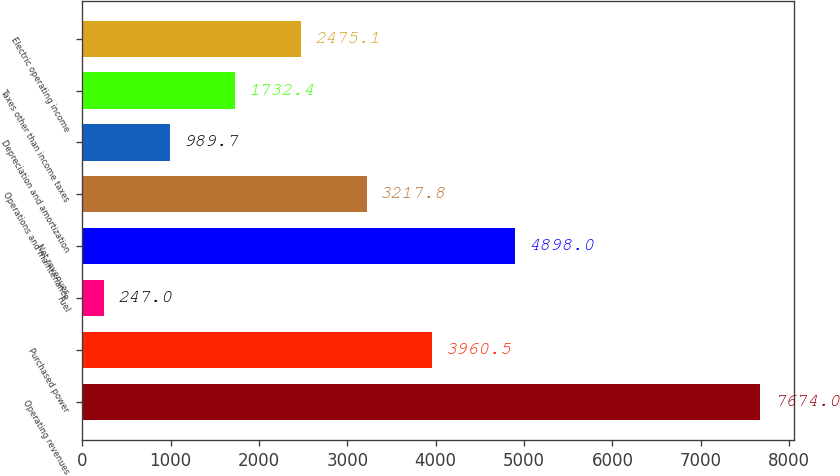<chart> <loc_0><loc_0><loc_500><loc_500><bar_chart><fcel>Operating revenues<fcel>Purchased power<fcel>Fuel<fcel>Net revenues<fcel>Operations and maintenance<fcel>Depreciation and amortization<fcel>Taxes other than income taxes<fcel>Electric operating income<nl><fcel>7674<fcel>3960.5<fcel>247<fcel>4898<fcel>3217.8<fcel>989.7<fcel>1732.4<fcel>2475.1<nl></chart> 